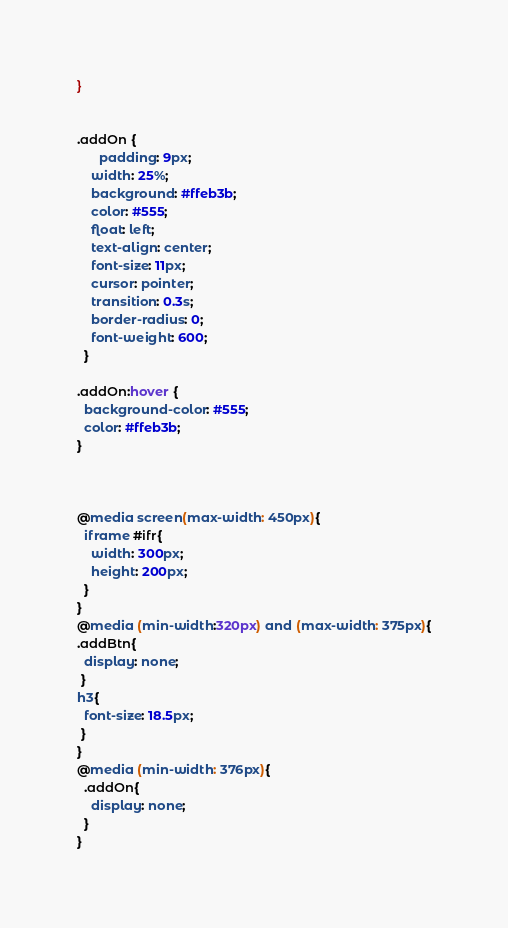Convert code to text. <code><loc_0><loc_0><loc_500><loc_500><_CSS_>}


.addOn {
      padding: 9px;
    width: 25%;
    background: #ffeb3b;
    color: #555;
    float: left;
    text-align: center;
    font-size: 11px;
    cursor: pointer;
    transition: 0.3s;
    border-radius: 0;
    font-weight: 600;
  }

.addOn:hover {
  background-color: #555;
  color: #ffeb3b;
}



@media screen(max-width: 450px){
  iframe #ifr{
    width: 300px;
    height: 200px;
  }
}
@media (min-width:320px) and (max-width: 375px){
.addBtn{
  display: none;
 }
h3{
  font-size: 18.5px;
 }
}
@media (min-width: 376px){
  .addOn{
    display: none;
  }
}</code> 